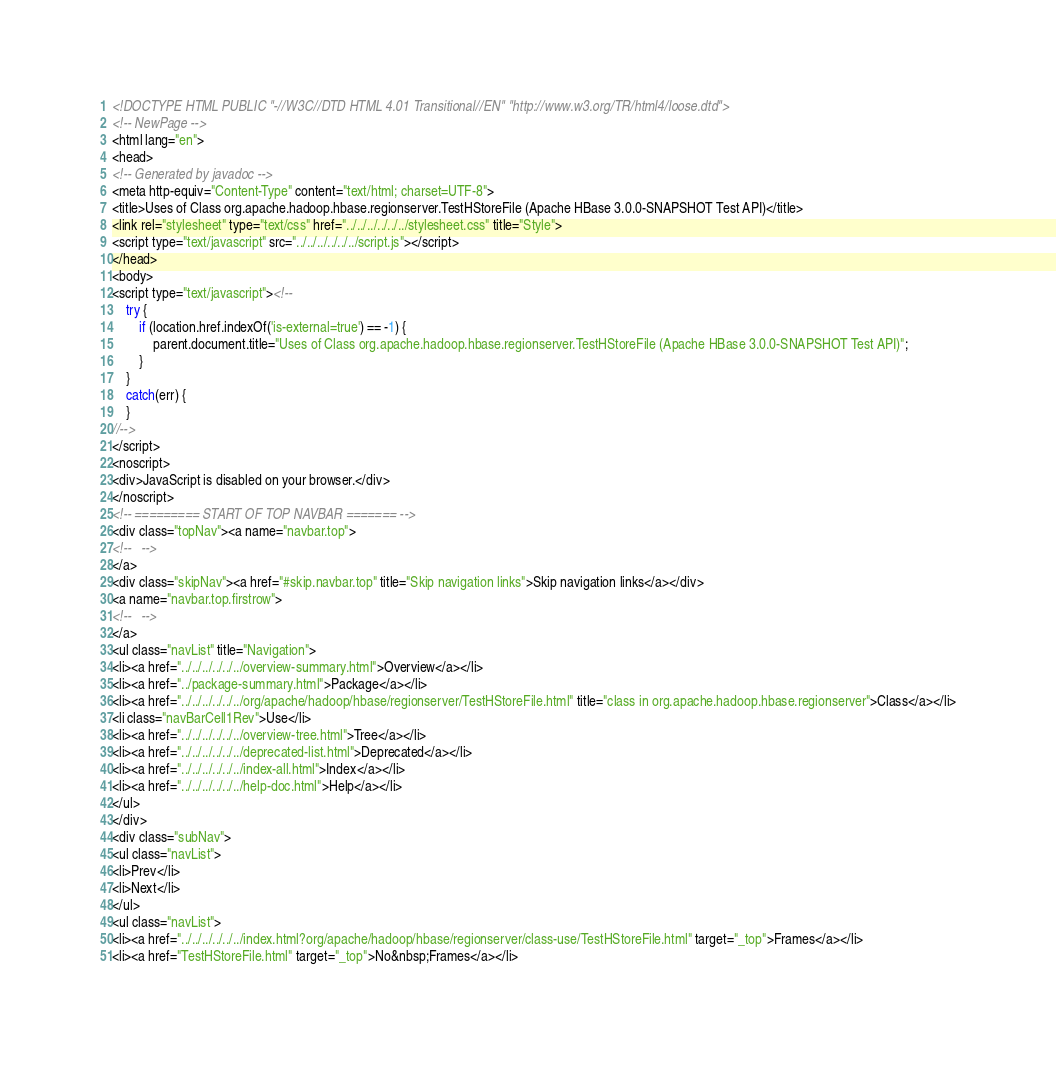Convert code to text. <code><loc_0><loc_0><loc_500><loc_500><_HTML_><!DOCTYPE HTML PUBLIC "-//W3C//DTD HTML 4.01 Transitional//EN" "http://www.w3.org/TR/html4/loose.dtd">
<!-- NewPage -->
<html lang="en">
<head>
<!-- Generated by javadoc -->
<meta http-equiv="Content-Type" content="text/html; charset=UTF-8">
<title>Uses of Class org.apache.hadoop.hbase.regionserver.TestHStoreFile (Apache HBase 3.0.0-SNAPSHOT Test API)</title>
<link rel="stylesheet" type="text/css" href="../../../../../../stylesheet.css" title="Style">
<script type="text/javascript" src="../../../../../../script.js"></script>
</head>
<body>
<script type="text/javascript"><!--
    try {
        if (location.href.indexOf('is-external=true') == -1) {
            parent.document.title="Uses of Class org.apache.hadoop.hbase.regionserver.TestHStoreFile (Apache HBase 3.0.0-SNAPSHOT Test API)";
        }
    }
    catch(err) {
    }
//-->
</script>
<noscript>
<div>JavaScript is disabled on your browser.</div>
</noscript>
<!-- ========= START OF TOP NAVBAR ======= -->
<div class="topNav"><a name="navbar.top">
<!--   -->
</a>
<div class="skipNav"><a href="#skip.navbar.top" title="Skip navigation links">Skip navigation links</a></div>
<a name="navbar.top.firstrow">
<!--   -->
</a>
<ul class="navList" title="Navigation">
<li><a href="../../../../../../overview-summary.html">Overview</a></li>
<li><a href="../package-summary.html">Package</a></li>
<li><a href="../../../../../../org/apache/hadoop/hbase/regionserver/TestHStoreFile.html" title="class in org.apache.hadoop.hbase.regionserver">Class</a></li>
<li class="navBarCell1Rev">Use</li>
<li><a href="../../../../../../overview-tree.html">Tree</a></li>
<li><a href="../../../../../../deprecated-list.html">Deprecated</a></li>
<li><a href="../../../../../../index-all.html">Index</a></li>
<li><a href="../../../../../../help-doc.html">Help</a></li>
</ul>
</div>
<div class="subNav">
<ul class="navList">
<li>Prev</li>
<li>Next</li>
</ul>
<ul class="navList">
<li><a href="../../../../../../index.html?org/apache/hadoop/hbase/regionserver/class-use/TestHStoreFile.html" target="_top">Frames</a></li>
<li><a href="TestHStoreFile.html" target="_top">No&nbsp;Frames</a></li></code> 